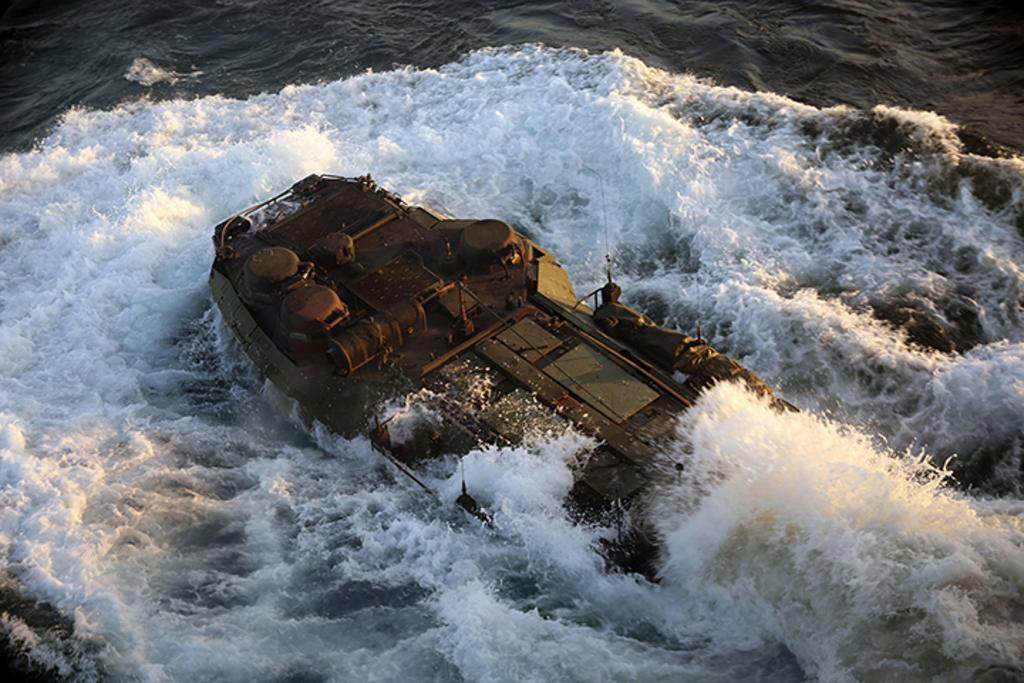What is the main subject of the image? The main subject of the image is a boat. Where is the boat located in the image? The boat is on the water. Can you see any snails crawling on the boat in the image? There are no snails visible on the boat in the image. What type of farm can be seen in the background of the image? There is no farm present in the image; it features a boat on the water. 